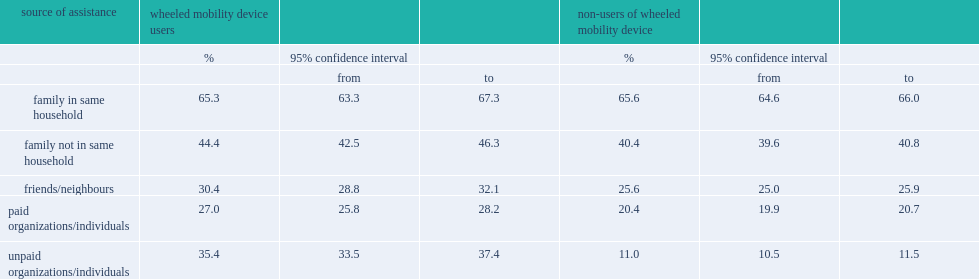How many percent of wheeled mobility device users have reported help from family members in the same household? 65.3. How many percent of wheeled mobility device users have reported help from family who lived elsewhere? 44.4. How many percent of wheeled mobility device users were assisted by unpaid organizations/individuals? 35.4. How many percent of wheeled mobility device users have paid for assistance? 27.0. Could you help me parse every detail presented in this table? {'header': ['source of assistance', 'wheeled mobility device users', '', '', 'non-users of wheeled mobility device', '', ''], 'rows': [['', '%', '95% confidence interval', '', '%', '95% confidence interval', ''], ['', '', 'from', 'to', '', 'from', 'to'], ['family in same household', '65.3', '63.3', '67.3', '65.6', '64.6', '66.0'], ['family not in same household', '44.4', '42.5', '46.3', '40.4', '39.6', '40.8'], ['friends/neighbours', '30.4', '28.8', '32.1', '25.6', '25.0', '25.9'], ['paid organizations/individuals', '27.0', '25.8', '28.2', '20.4', '19.9', '20.7'], ['unpaid organizations/individuals', '35.4', '33.5', '37.4', '11.0', '10.5', '11.5']]} 